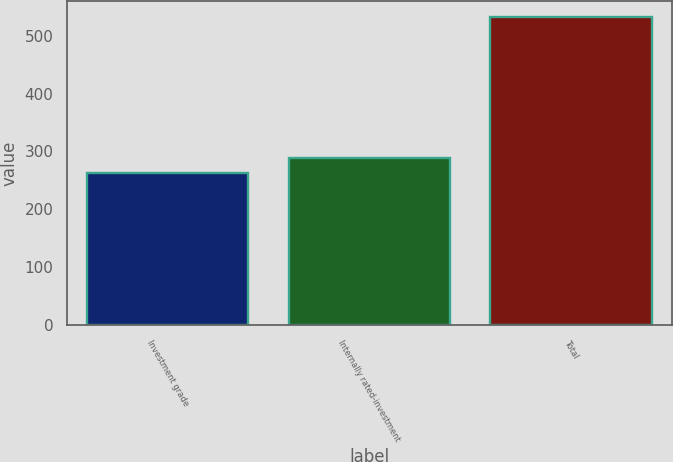<chart> <loc_0><loc_0><loc_500><loc_500><bar_chart><fcel>Investment grade<fcel>Internally rated-investment<fcel>Total<nl><fcel>262<fcel>289.1<fcel>533<nl></chart> 